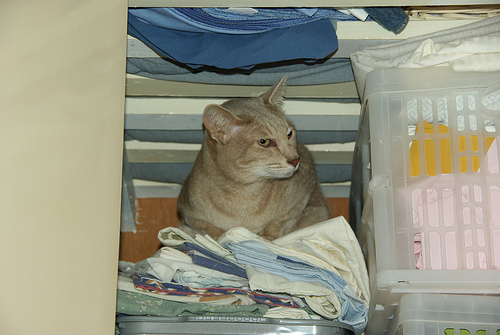<image>
Is there a cat on the dress? Yes. Looking at the image, I can see the cat is positioned on top of the dress, with the dress providing support. Is the cat in front of the wood? Yes. The cat is positioned in front of the wood, appearing closer to the camera viewpoint. 